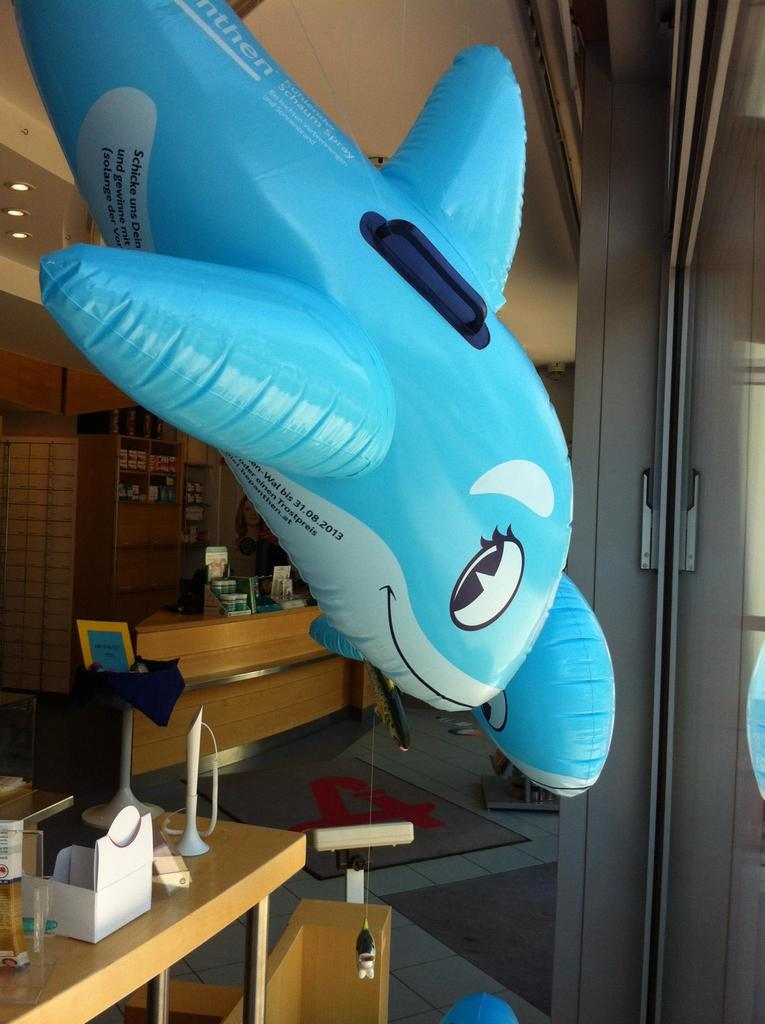<image>
Relay a brief, clear account of the picture shown. An inflatable dolphin with the numbers 31.08.2013 on it hangs above a counter. 